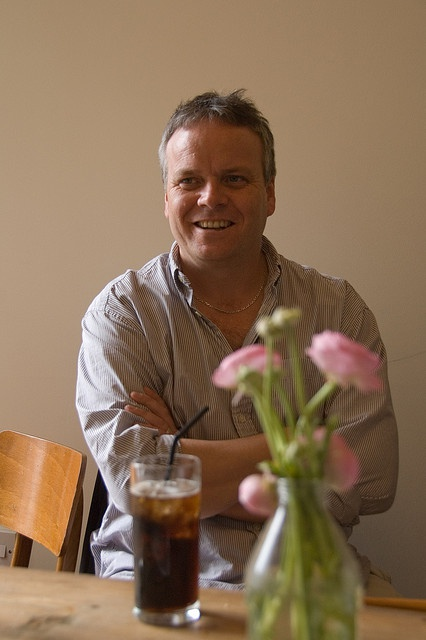Describe the objects in this image and their specific colors. I can see people in tan, maroon, gray, and lightgray tones, vase in tan, olive, and darkgray tones, dining table in tan, gray, and maroon tones, cup in tan, black, maroon, and gray tones, and chair in tan, orange, and maroon tones in this image. 